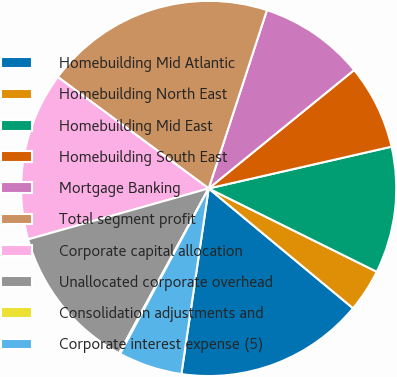Convert chart. <chart><loc_0><loc_0><loc_500><loc_500><pie_chart><fcel>Homebuilding Mid Atlantic<fcel>Homebuilding North East<fcel>Homebuilding Mid East<fcel>Homebuilding South East<fcel>Mortgage Banking<fcel>Total segment profit<fcel>Corporate capital allocation<fcel>Unallocated corporate overhead<fcel>Consolidation adjustments and<fcel>Corporate interest expense (5)<nl><fcel>16.3%<fcel>3.7%<fcel>10.9%<fcel>7.3%<fcel>9.1%<fcel>19.9%<fcel>14.5%<fcel>12.7%<fcel>0.1%<fcel>5.5%<nl></chart> 